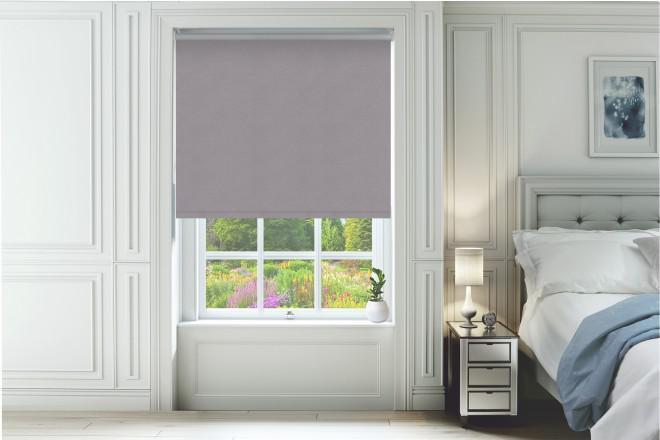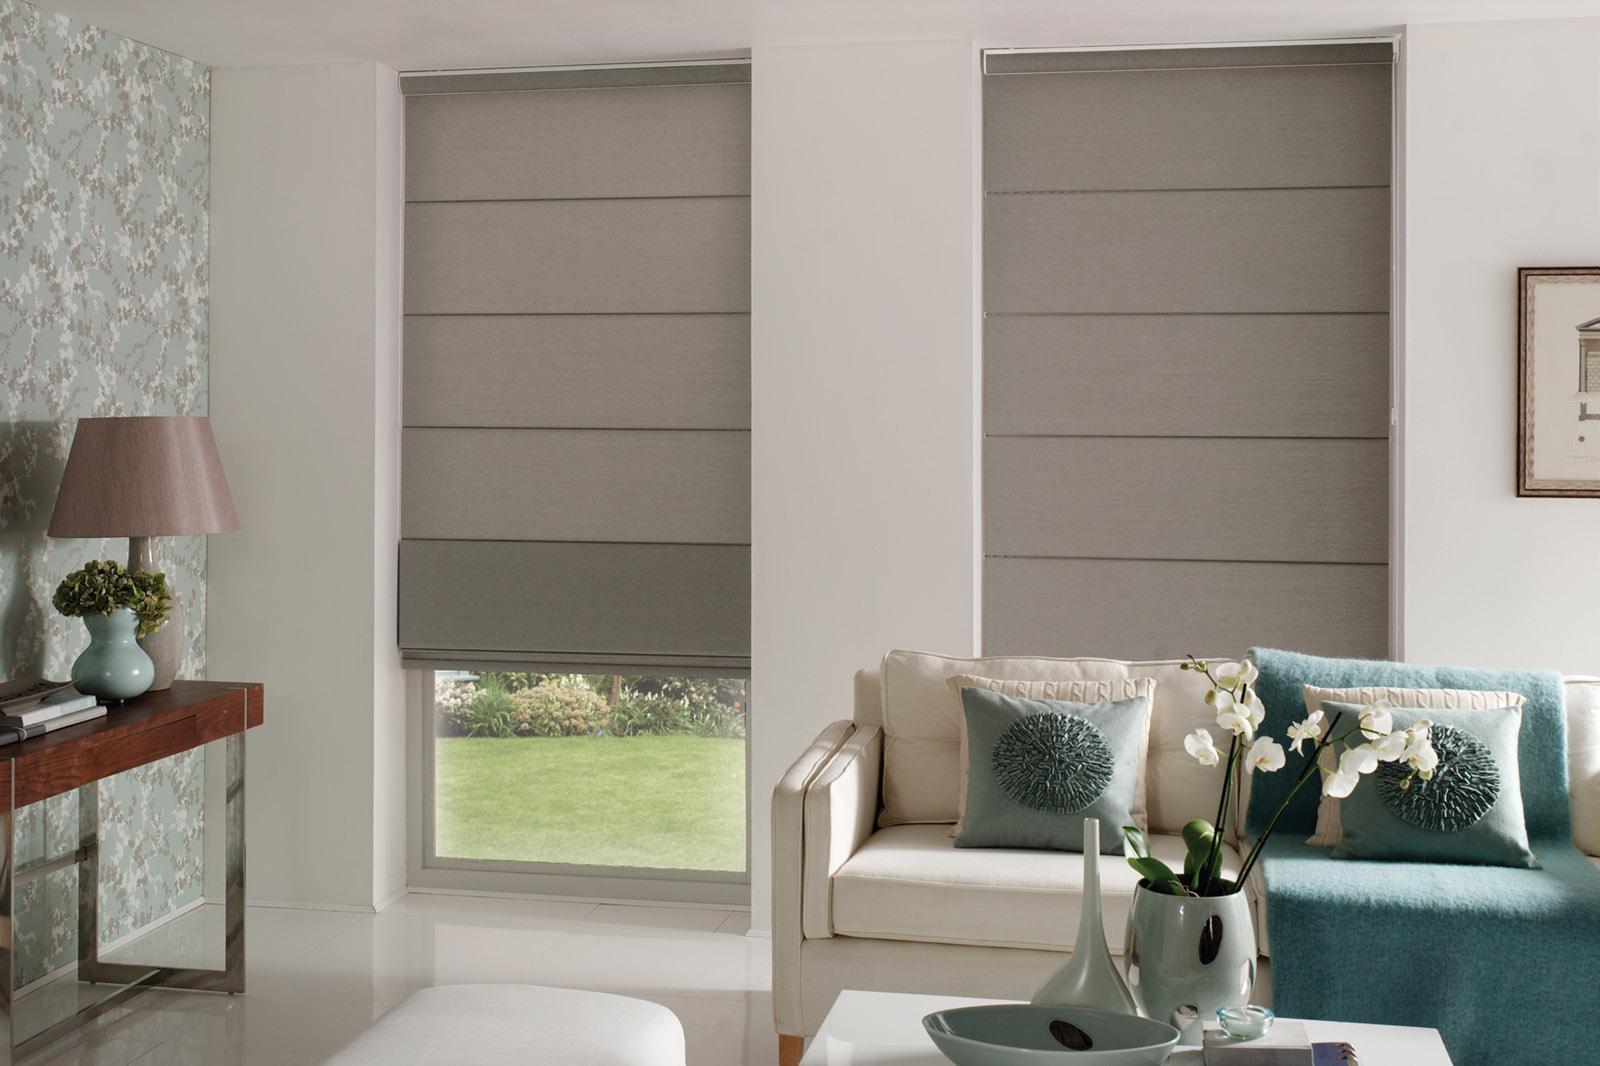The first image is the image on the left, the second image is the image on the right. For the images displayed, is the sentence "There are exactly three window shades." factually correct? Answer yes or no. Yes. The first image is the image on the left, the second image is the image on the right. For the images shown, is this caption "The left and right image contains a total of three blinds." true? Answer yes or no. Yes. 